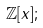Convert formula to latex. <formula><loc_0><loc_0><loc_500><loc_500>\mathbb { Z } [ x ] ;</formula> 